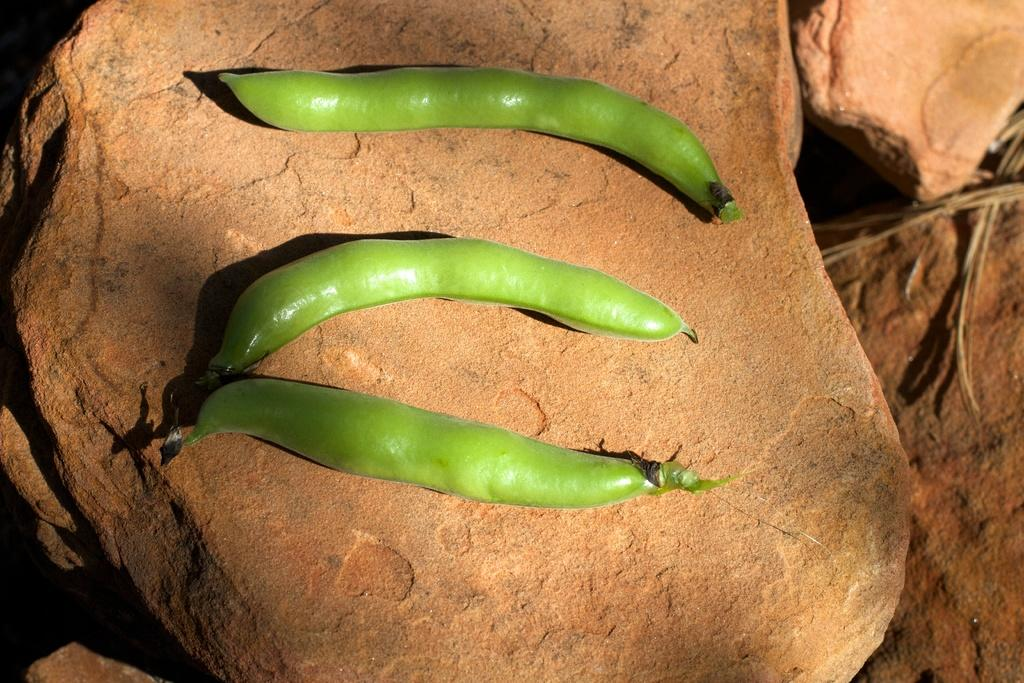What type of vegetables can be seen in the image? There are three green color vegetables in the image. Where are the vegetables placed? The vegetables are on a stone. Are there any other stones visible in the image? Yes, there are other stones visible in the image. Can you see a volleyball being played on the stones in the image? There is no volleyball or any indication of a game being played in the image. 